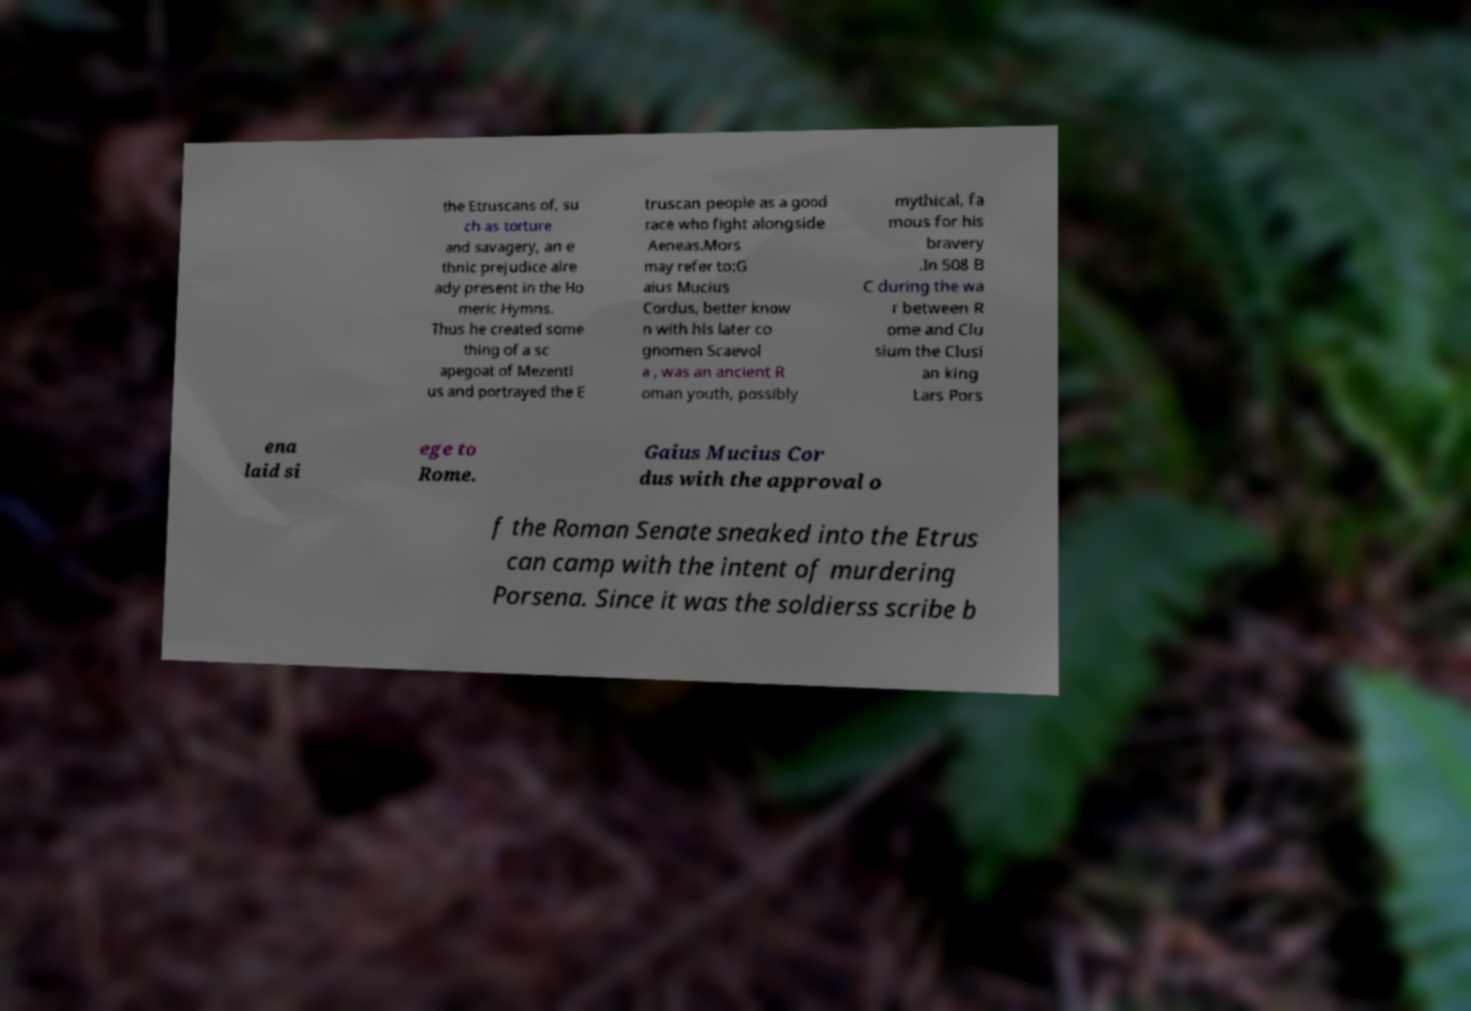For documentation purposes, I need the text within this image transcribed. Could you provide that? the Etruscans of, su ch as torture and savagery, an e thnic prejudice alre ady present in the Ho meric Hymns. Thus he created some thing of a sc apegoat of Mezenti us and portrayed the E truscan people as a good race who fight alongside Aeneas.Mors may refer to:G aius Mucius Cordus, better know n with his later co gnomen Scaevol a , was an ancient R oman youth, possibly mythical, fa mous for his bravery .In 508 B C during the wa r between R ome and Clu sium the Clusi an king Lars Pors ena laid si ege to Rome. Gaius Mucius Cor dus with the approval o f the Roman Senate sneaked into the Etrus can camp with the intent of murdering Porsena. Since it was the soldierss scribe b 